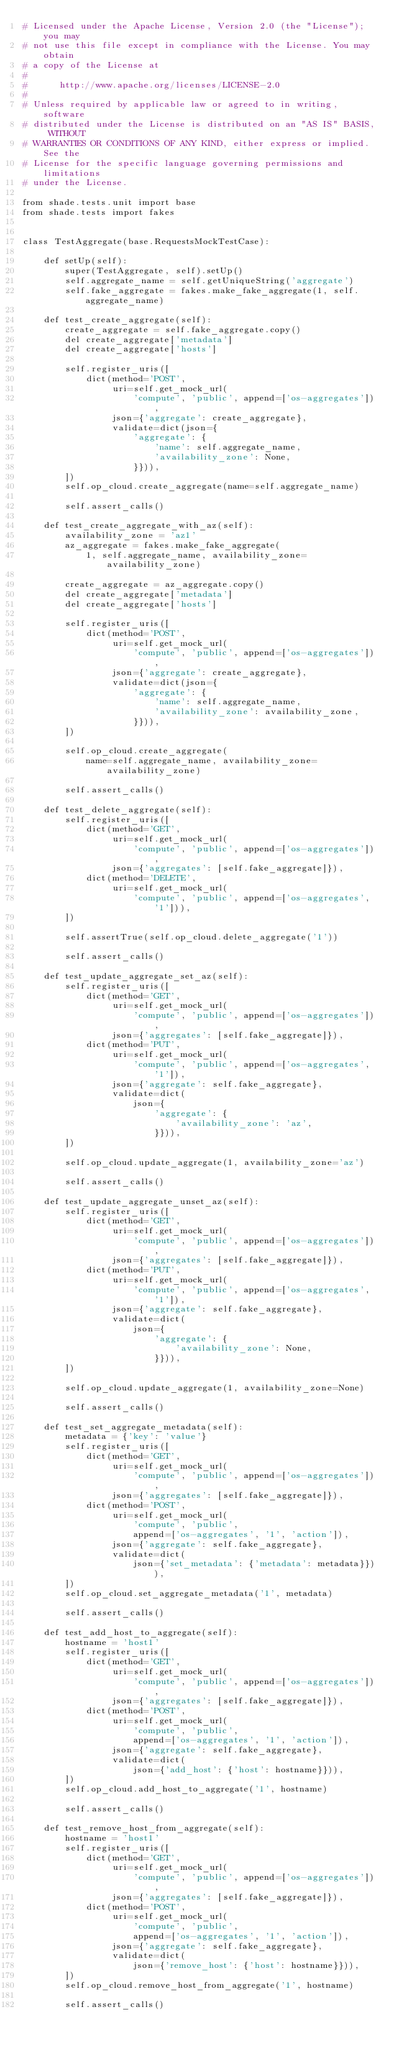Convert code to text. <code><loc_0><loc_0><loc_500><loc_500><_Python_># Licensed under the Apache License, Version 2.0 (the "License"); you may
# not use this file except in compliance with the License. You may obtain
# a copy of the License at
#
#      http://www.apache.org/licenses/LICENSE-2.0
#
# Unless required by applicable law or agreed to in writing, software
# distributed under the License is distributed on an "AS IS" BASIS, WITHOUT
# WARRANTIES OR CONDITIONS OF ANY KIND, either express or implied. See the
# License for the specific language governing permissions and limitations
# under the License.

from shade.tests.unit import base
from shade.tests import fakes


class TestAggregate(base.RequestsMockTestCase):

    def setUp(self):
        super(TestAggregate, self).setUp()
        self.aggregate_name = self.getUniqueString('aggregate')
        self.fake_aggregate = fakes.make_fake_aggregate(1, self.aggregate_name)

    def test_create_aggregate(self):
        create_aggregate = self.fake_aggregate.copy()
        del create_aggregate['metadata']
        del create_aggregate['hosts']

        self.register_uris([
            dict(method='POST',
                 uri=self.get_mock_url(
                     'compute', 'public', append=['os-aggregates']),
                 json={'aggregate': create_aggregate},
                 validate=dict(json={
                     'aggregate': {
                         'name': self.aggregate_name,
                         'availability_zone': None,
                     }})),
        ])
        self.op_cloud.create_aggregate(name=self.aggregate_name)

        self.assert_calls()

    def test_create_aggregate_with_az(self):
        availability_zone = 'az1'
        az_aggregate = fakes.make_fake_aggregate(
            1, self.aggregate_name, availability_zone=availability_zone)

        create_aggregate = az_aggregate.copy()
        del create_aggregate['metadata']
        del create_aggregate['hosts']

        self.register_uris([
            dict(method='POST',
                 uri=self.get_mock_url(
                     'compute', 'public', append=['os-aggregates']),
                 json={'aggregate': create_aggregate},
                 validate=dict(json={
                     'aggregate': {
                         'name': self.aggregate_name,
                         'availability_zone': availability_zone,
                     }})),
        ])

        self.op_cloud.create_aggregate(
            name=self.aggregate_name, availability_zone=availability_zone)

        self.assert_calls()

    def test_delete_aggregate(self):
        self.register_uris([
            dict(method='GET',
                 uri=self.get_mock_url(
                     'compute', 'public', append=['os-aggregates']),
                 json={'aggregates': [self.fake_aggregate]}),
            dict(method='DELETE',
                 uri=self.get_mock_url(
                     'compute', 'public', append=['os-aggregates', '1'])),
        ])

        self.assertTrue(self.op_cloud.delete_aggregate('1'))

        self.assert_calls()

    def test_update_aggregate_set_az(self):
        self.register_uris([
            dict(method='GET',
                 uri=self.get_mock_url(
                     'compute', 'public', append=['os-aggregates']),
                 json={'aggregates': [self.fake_aggregate]}),
            dict(method='PUT',
                 uri=self.get_mock_url(
                     'compute', 'public', append=['os-aggregates', '1']),
                 json={'aggregate': self.fake_aggregate},
                 validate=dict(
                     json={
                         'aggregate': {
                             'availability_zone': 'az',
                         }})),
        ])

        self.op_cloud.update_aggregate(1, availability_zone='az')

        self.assert_calls()

    def test_update_aggregate_unset_az(self):
        self.register_uris([
            dict(method='GET',
                 uri=self.get_mock_url(
                     'compute', 'public', append=['os-aggregates']),
                 json={'aggregates': [self.fake_aggregate]}),
            dict(method='PUT',
                 uri=self.get_mock_url(
                     'compute', 'public', append=['os-aggregates', '1']),
                 json={'aggregate': self.fake_aggregate},
                 validate=dict(
                     json={
                         'aggregate': {
                             'availability_zone': None,
                         }})),
        ])

        self.op_cloud.update_aggregate(1, availability_zone=None)

        self.assert_calls()

    def test_set_aggregate_metadata(self):
        metadata = {'key': 'value'}
        self.register_uris([
            dict(method='GET',
                 uri=self.get_mock_url(
                     'compute', 'public', append=['os-aggregates']),
                 json={'aggregates': [self.fake_aggregate]}),
            dict(method='POST',
                 uri=self.get_mock_url(
                     'compute', 'public',
                     append=['os-aggregates', '1', 'action']),
                 json={'aggregate': self.fake_aggregate},
                 validate=dict(
                     json={'set_metadata': {'metadata': metadata}})),
        ])
        self.op_cloud.set_aggregate_metadata('1', metadata)

        self.assert_calls()

    def test_add_host_to_aggregate(self):
        hostname = 'host1'
        self.register_uris([
            dict(method='GET',
                 uri=self.get_mock_url(
                     'compute', 'public', append=['os-aggregates']),
                 json={'aggregates': [self.fake_aggregate]}),
            dict(method='POST',
                 uri=self.get_mock_url(
                     'compute', 'public',
                     append=['os-aggregates', '1', 'action']),
                 json={'aggregate': self.fake_aggregate},
                 validate=dict(
                     json={'add_host': {'host': hostname}})),
        ])
        self.op_cloud.add_host_to_aggregate('1', hostname)

        self.assert_calls()

    def test_remove_host_from_aggregate(self):
        hostname = 'host1'
        self.register_uris([
            dict(method='GET',
                 uri=self.get_mock_url(
                     'compute', 'public', append=['os-aggregates']),
                 json={'aggregates': [self.fake_aggregate]}),
            dict(method='POST',
                 uri=self.get_mock_url(
                     'compute', 'public',
                     append=['os-aggregates', '1', 'action']),
                 json={'aggregate': self.fake_aggregate},
                 validate=dict(
                     json={'remove_host': {'host': hostname}})),
        ])
        self.op_cloud.remove_host_from_aggregate('1', hostname)

        self.assert_calls()
</code> 